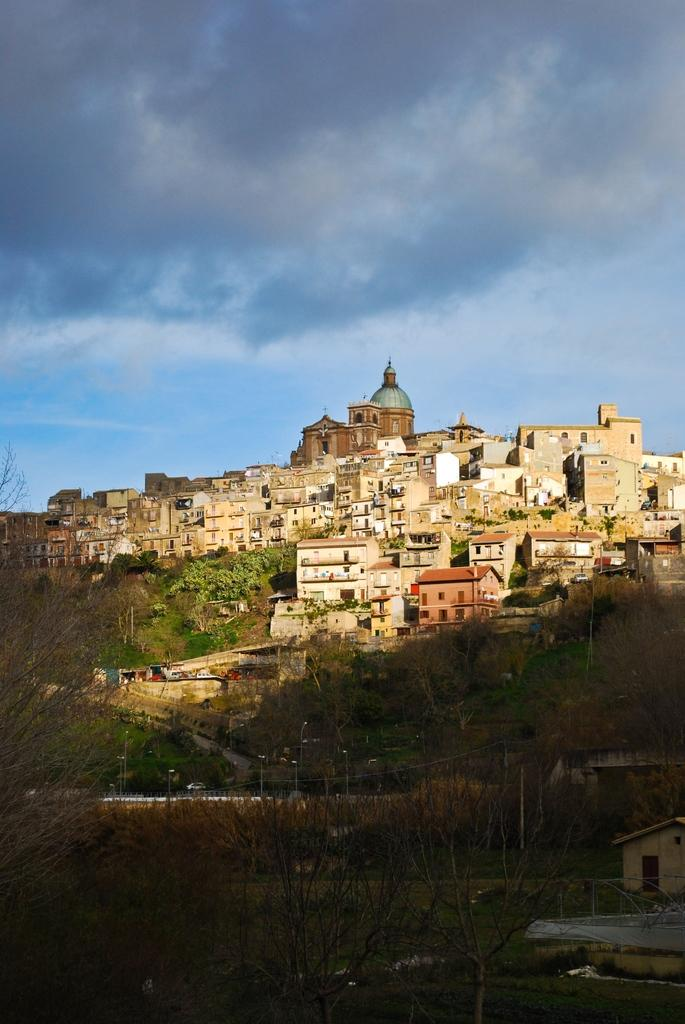What type of structures can be seen in the image? There are buildings in the image. What else can be seen in the image besides buildings? There are poles, the ground, grass, plants, trees, and the sky visible in the image. What is the condition of the sky in the image? The sky is visible in the image, and clouds are present. What type of scent can be detected from the plants in the image? There is no information about the scent of the plants in the image, so it cannot be determined. --- Facts: 1. There is a person in the image. 2. The person is wearing a hat. 3. The person is holding a book. 4. There is a table in the image. 5. The table has a lamp on it. Absurd Topics: parrot, bicycle, ocean Conversation: What is the main subject of the image? The main subject of the image is a person. What is the person wearing in the image? The person is wearing a hat in the image. What is the person holding in the image? The person is holding a book in the image. What object is present on the table in the image? There is a lamp on the table in the image. Reasoning: Let's think step by step in order to produce the conversation. We start by identifying the main subject of the image, which is the person. Then, we describe the person's attire and what they are holding, which is a hat and a book, respectively. Finally, we mention the object on the table, which is a lamp. Each question is designed to elicit a specific detail about the image that is known from the provided facts. Absurd Question/Answer: Can you see a parrot sitting on the person's shoulder in the image? No, there is no parrot present in the image. 